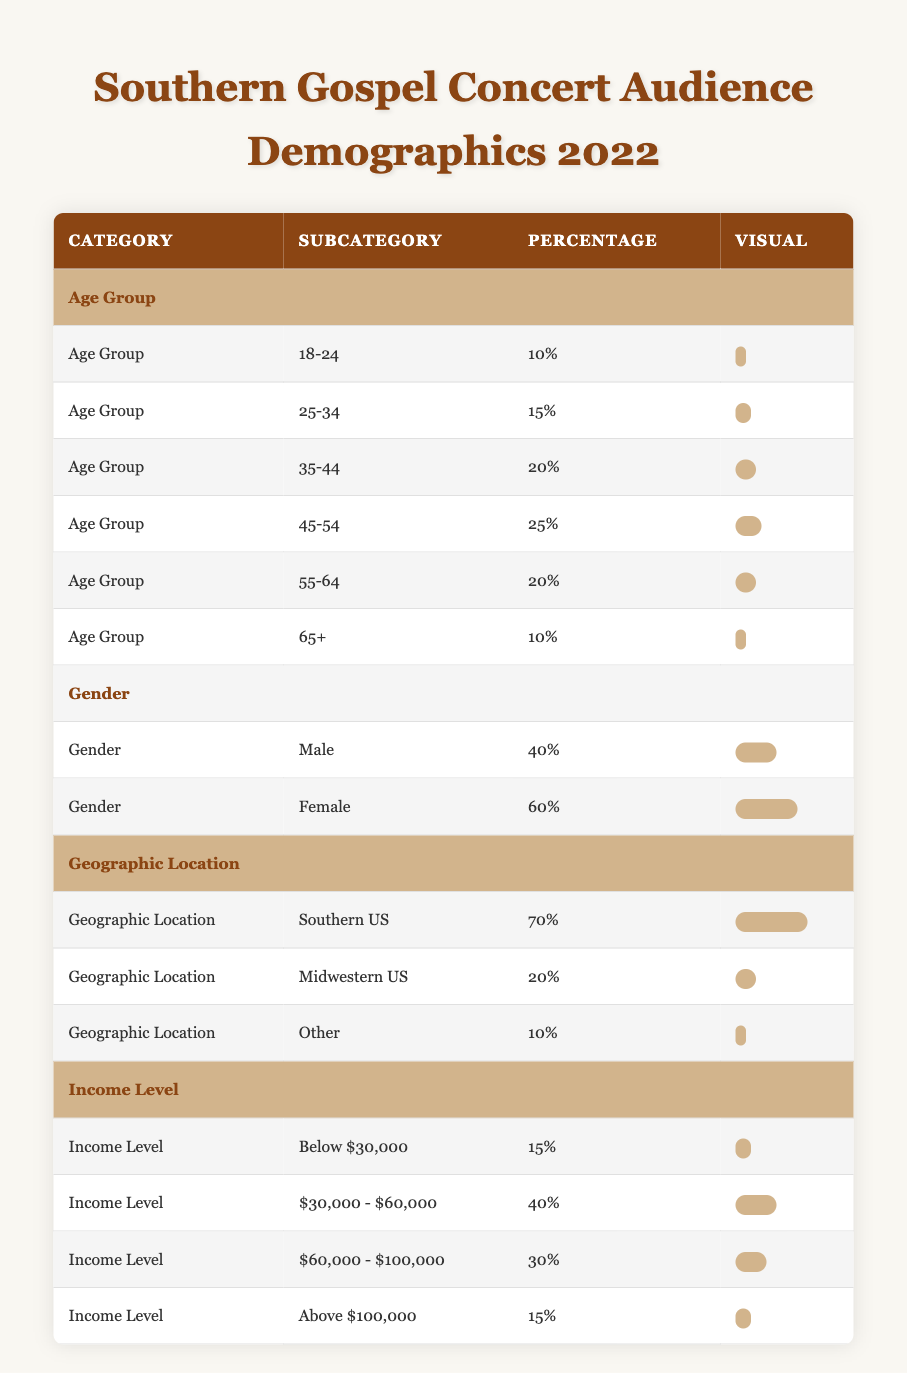What percentage of the audience at Southern Gospel concerts in 2022 were aged 45-54? From the table, I locate the age group 45-54, which shows a percentage of 25%.
Answer: 25% What is the total percentage of female attendees at the concerts? The table lists female attendees at 60%, so that is the total percentage for female attendees as only male and female are present.
Answer: 60% Which region had the largest audience share for Southern Gospel concerts? The table indicates that the Southern US region had 70%, which is greater than the 20% from the Midwestern US and 10% from Other regions.
Answer: Southern US Is the percentage of concertgoers aged 65 and older equal to those earning above $100,000? The percentage of attendees aged 65 and older is 10%, while the percentage earning above $100,000 is also 15%, thus they are not equal.
Answer: No What age group has the highest percentage of concertgoers, and what is that percentage? The age group 45-54 has the highest percentage at 25%, which is greater than the next highest group of 35-44 at 20%.
Answer: 25% What is the average percentage of attendees in the age groups from 25-34 and 35-44? The percentages for 25-34 and 35-44 are 15% and 20%, respectively. Sum these to get 35% and divide by 2 for an average of 17.5%.
Answer: 17.5% How do the percentages of income levels compare for those earning below $30,000 versus those earning $60,000 - $100,000? The table shows 15% for below $30,000 and 30% for $60,000 - $100,000. Therefore, 30% is larger than 15%.
Answer: Yes What is the difference in the percentage of concertgoers between the Southern US and Midwestern US regions? The Southern US has 70% and the Midwestern US has 20%. The difference is 70% - 20% = 50%.
Answer: 50% How many demographics categories are presented in the table, and what are they? The table displays four categories: Age Group, Gender, Geographic Location, and Income Level. Counting these yields four distinct categories.
Answer: 4 